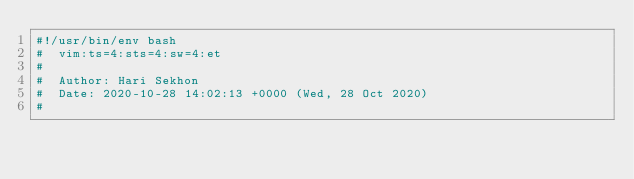Convert code to text. <code><loc_0><loc_0><loc_500><loc_500><_Bash_>#!/usr/bin/env bash
#  vim:ts=4:sts=4:sw=4:et
#
#  Author: Hari Sekhon
#  Date: 2020-10-28 14:02:13 +0000 (Wed, 28 Oct 2020)
#</code> 